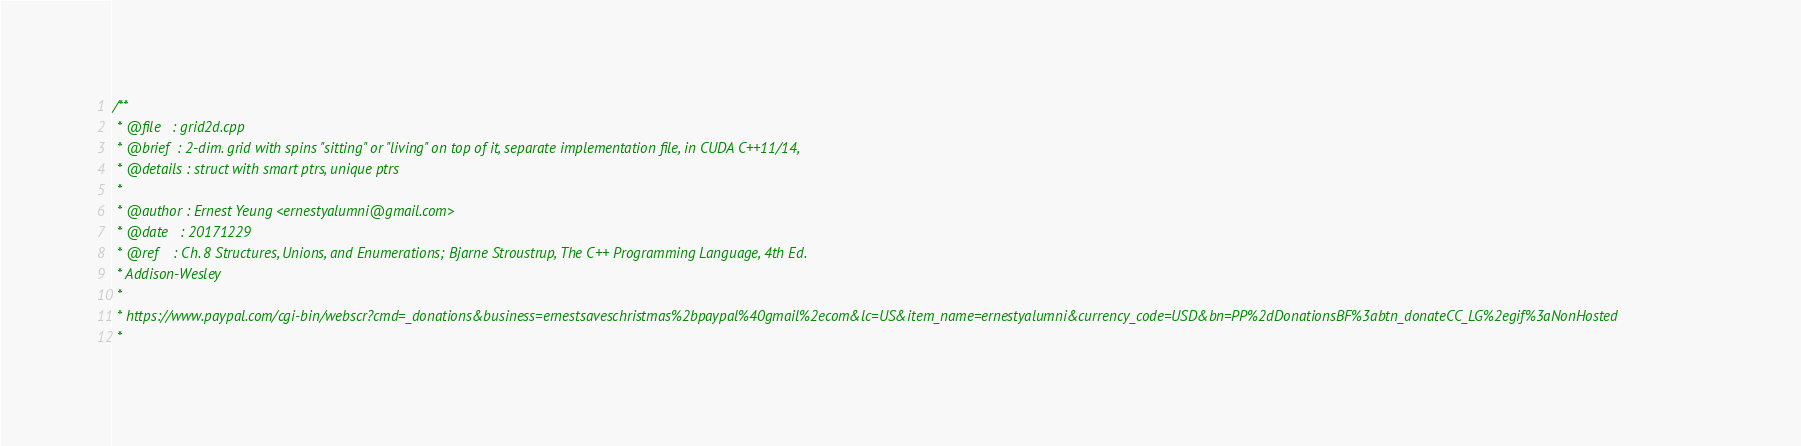Convert code to text. <code><loc_0><loc_0><loc_500><loc_500><_Cuda_>/**
 * @file   : grid2d.cpp
 * @brief  : 2-dim. grid with spins "sitting" or "living" on top of it, separate implementation file, in CUDA C++11/14, 
 * @details : struct with smart ptrs, unique ptrs  
 * 
 * @author : Ernest Yeung <ernestyalumni@gmail.com>
 * @date   : 20171229    
 * @ref    : Ch. 8 Structures, Unions, and Enumerations; Bjarne Stroustrup, The C++ Programming Language, 4th Ed.  
 * Addison-Wesley 
 * 
 * https://www.paypal.com/cgi-bin/webscr?cmd=_donations&business=ernestsaveschristmas%2bpaypal%40gmail%2ecom&lc=US&item_name=ernestyalumni&currency_code=USD&bn=PP%2dDonationsBF%3abtn_donateCC_LG%2egif%3aNonHosted 
 * </code> 